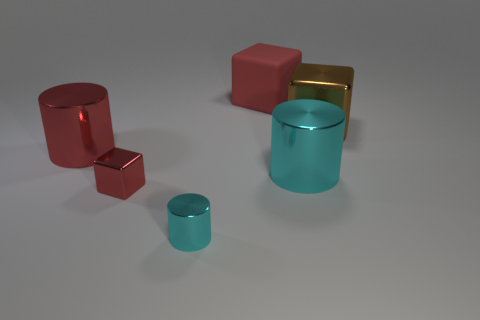Do the big rubber cube and the small metal cube have the same color?
Keep it short and to the point. Yes. The small shiny thing that is the same color as the large rubber block is what shape?
Keep it short and to the point. Cube. There is a cylinder that is the same color as the matte block; what size is it?
Make the answer very short. Large. What is the color of the big cylinder that is left of the small cylinder?
Provide a succinct answer. Red. Is the large cylinder that is on the right side of the tiny cylinder made of the same material as the large brown cube?
Offer a terse response. Yes. How many blocks are on the left side of the big cyan cylinder and on the right side of the small cyan object?
Offer a terse response. 1. What is the color of the metal cube that is in front of the large metal cylinder that is right of the tiny block to the left of the rubber block?
Ensure brevity in your answer.  Red. What number of other things are there of the same shape as the large red metallic thing?
Ensure brevity in your answer.  2. Is there a brown shiny block that is to the left of the shiny block on the left side of the brown metallic block?
Keep it short and to the point. No. What number of shiny objects are big gray things or big cyan things?
Make the answer very short. 1. 